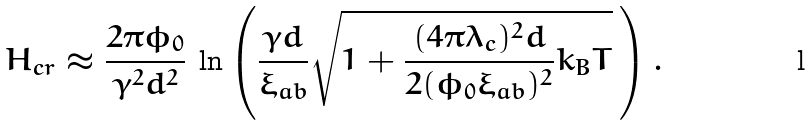<formula> <loc_0><loc_0><loc_500><loc_500>H _ { c r } \approx \frac { 2 \pi \phi _ { 0 } } { \gamma ^ { 2 } d ^ { 2 } } \, \ln \left ( \frac { \gamma d } { \xi _ { a b } } \sqrt { 1 + \frac { ( 4 \pi \lambda _ { c } ) ^ { 2 } d } { 2 ( \phi _ { 0 } \xi _ { a b } ) ^ { 2 } } k _ { B } T } \, \right ) .</formula> 